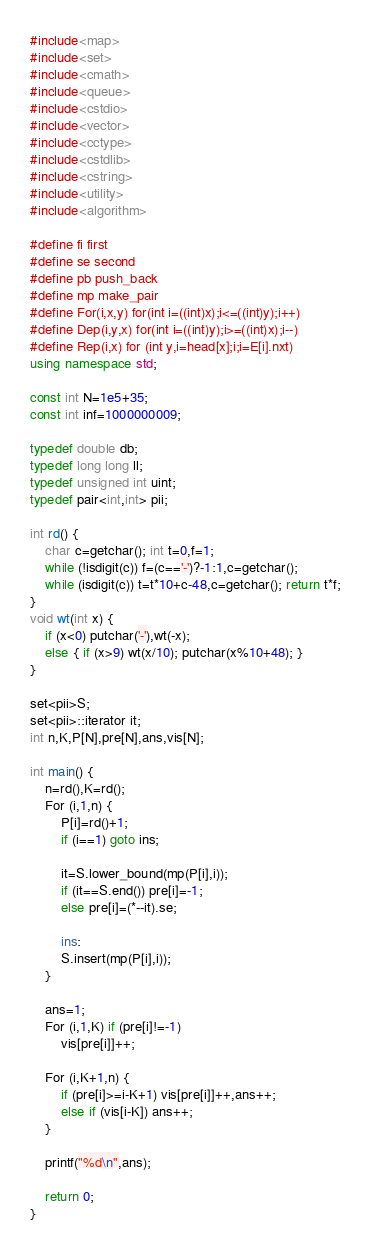Convert code to text. <code><loc_0><loc_0><loc_500><loc_500><_C++_>#include<map>
#include<set>
#include<cmath>
#include<queue>
#include<cstdio>
#include<vector>
#include<cctype>
#include<cstdlib>
#include<cstring>
#include<utility>
#include<algorithm>

#define fi first
#define se second
#define pb push_back
#define mp make_pair
#define For(i,x,y) for(int i=((int)x);i<=((int)y);i++)
#define Dep(i,y,x) for(int i=((int)y);i>=((int)x);i--)
#define Rep(i,x) for (int y,i=head[x];i;i=E[i].nxt)
using namespace std;

const int N=1e5+35;
const int inf=1000000009;

typedef double db;
typedef long long ll;
typedef unsigned int uint;
typedef pair<int,int> pii;

int rd() {
	char c=getchar(); int t=0,f=1;
	while (!isdigit(c)) f=(c=='-')?-1:1,c=getchar();
	while (isdigit(c)) t=t*10+c-48,c=getchar(); return t*f;
}
void wt(int x) {
	if (x<0) putchar('-'),wt(-x);
	else { if (x>9) wt(x/10); putchar(x%10+48); }
}

set<pii>S;
set<pii>::iterator it;
int n,K,P[N],pre[N],ans,vis[N];

int main() {
	n=rd(),K=rd();
	For (i,1,n) {
		P[i]=rd()+1;
		if (i==1) goto ins;
		
		it=S.lower_bound(mp(P[i],i));
		if (it==S.end()) pre[i]=-1;
		else pre[i]=(*--it).se;
	
		ins:
		S.insert(mp(P[i],i));
	}
	
	ans=1;
	For (i,1,K) if (pre[i]!=-1)
		vis[pre[i]]++;
	
	For (i,K+1,n) {
		if (pre[i]>=i-K+1) vis[pre[i]]++,ans++;
		else if (vis[i-K]) ans++;
	}
	
	printf("%d\n",ans);
	
	return 0;
}




</code> 